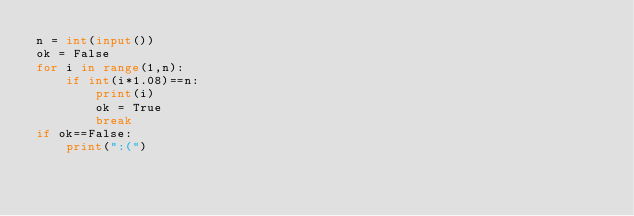Convert code to text. <code><loc_0><loc_0><loc_500><loc_500><_Python_>n = int(input())
ok = False
for i in range(1,n):
    if int(i*1.08)==n:
        print(i)
        ok = True
        break
if ok==False:
    print(":(")
</code> 